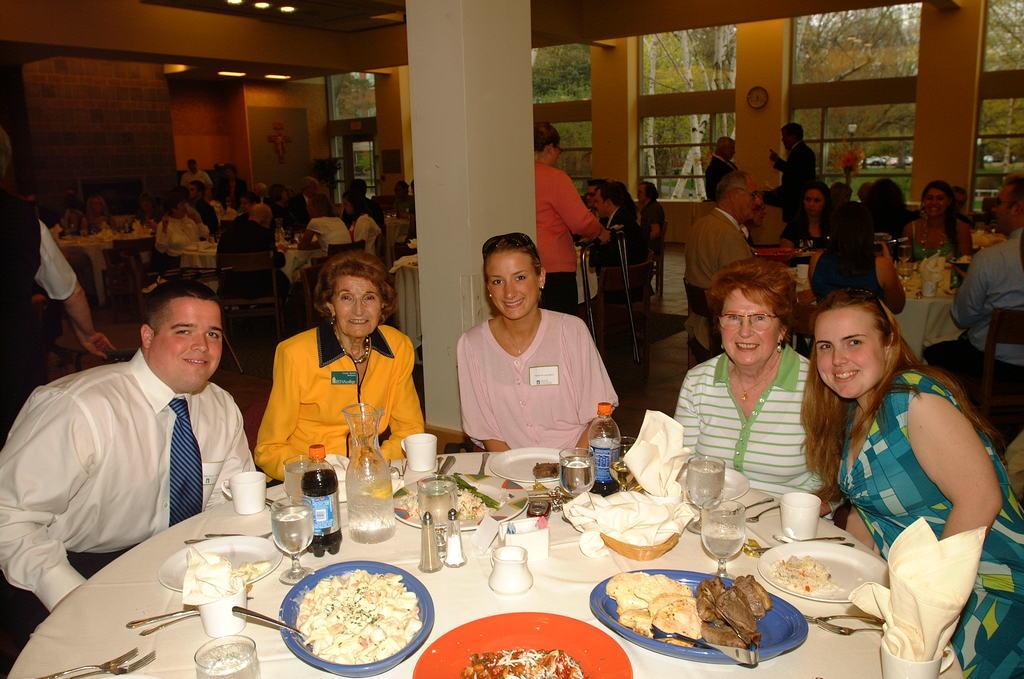In one or two sentences, can you explain what this image depicts? In this image there are groups of persons sitting on the chair, there are tables, there are objects on the tables, there is a pillar towards the top of the image, there is a wall, there is a wall clock, there are trees, there is a roof towards the top of the image, there are lights towards the top of the image. 